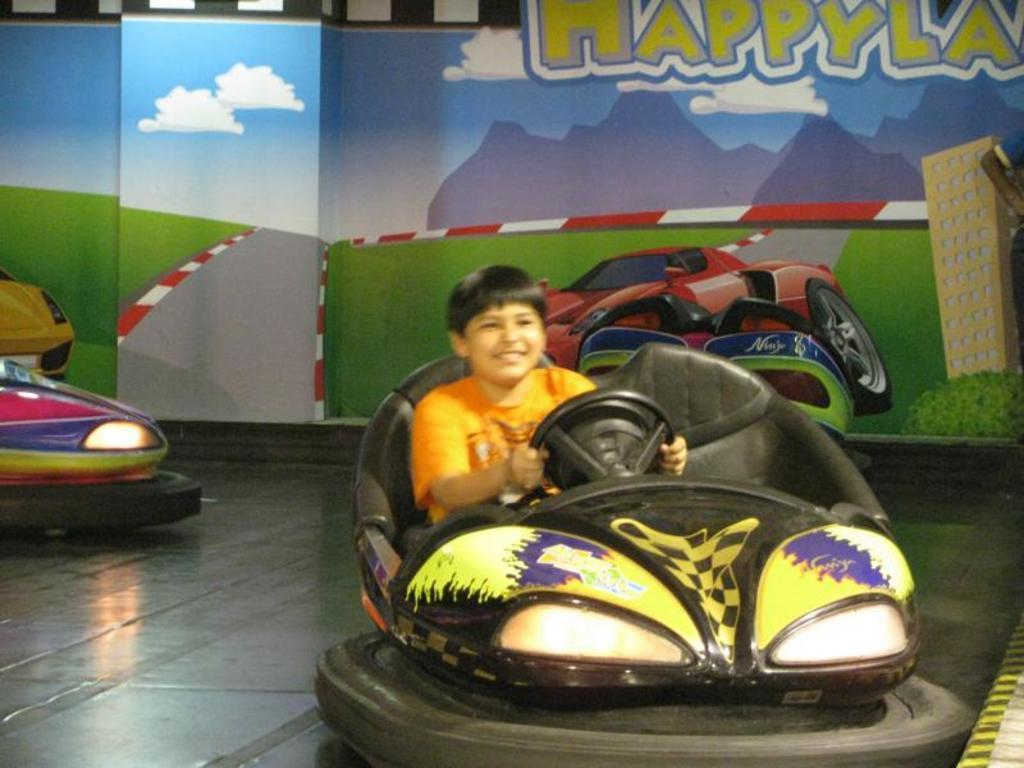Who is the main subject in the image? There is a boy in the image. What is the boy doing in the image? The boy is sitting in a cart and driving it. What can be seen in the background of the image? There is a wall with paintings in the background of the image. How many baby mice are crawling on the boy's lap in the image? There are no baby mice present in the image; the boy is sitting in a cart and driving it. 